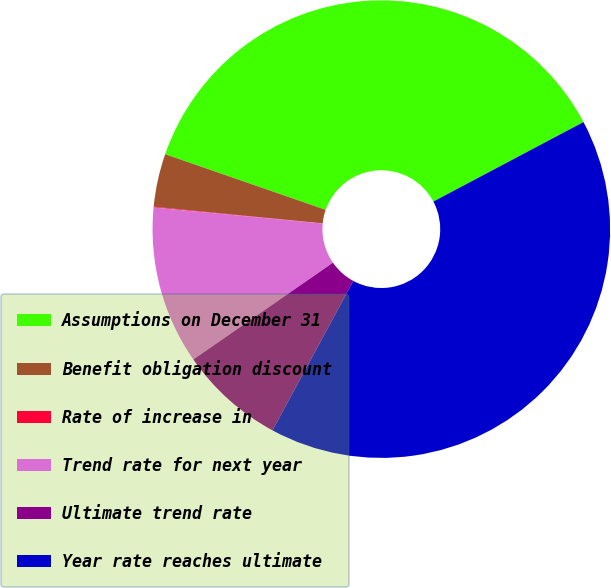Convert chart to OTSL. <chart><loc_0><loc_0><loc_500><loc_500><pie_chart><fcel>Assumptions on December 31<fcel>Benefit obligation discount<fcel>Rate of increase in<fcel>Trend rate for next year<fcel>Ultimate trend rate<fcel>Year rate reaches ultimate<nl><fcel>36.94%<fcel>3.75%<fcel>0.05%<fcel>11.16%<fcel>7.46%<fcel>40.64%<nl></chart> 